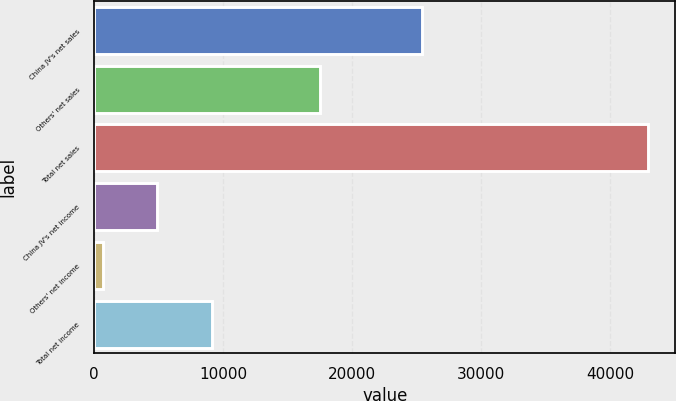<chart> <loc_0><loc_0><loc_500><loc_500><bar_chart><fcel>China JV's net sales<fcel>Others' net sales<fcel>Total net sales<fcel>China JV's net income<fcel>Others' net income<fcel>Total net income<nl><fcel>25395<fcel>17500<fcel>42895<fcel>4879.9<fcel>656<fcel>9103.8<nl></chart> 